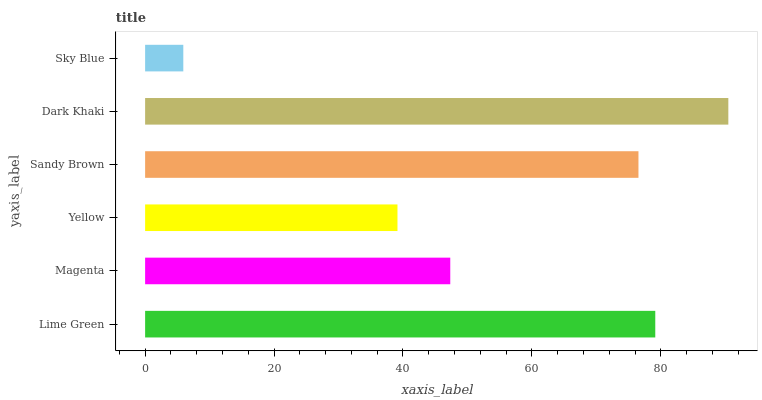Is Sky Blue the minimum?
Answer yes or no. Yes. Is Dark Khaki the maximum?
Answer yes or no. Yes. Is Magenta the minimum?
Answer yes or no. No. Is Magenta the maximum?
Answer yes or no. No. Is Lime Green greater than Magenta?
Answer yes or no. Yes. Is Magenta less than Lime Green?
Answer yes or no. Yes. Is Magenta greater than Lime Green?
Answer yes or no. No. Is Lime Green less than Magenta?
Answer yes or no. No. Is Sandy Brown the high median?
Answer yes or no. Yes. Is Magenta the low median?
Answer yes or no. Yes. Is Magenta the high median?
Answer yes or no. No. Is Sky Blue the low median?
Answer yes or no. No. 